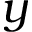<formula> <loc_0><loc_0><loc_500><loc_500>y</formula> 